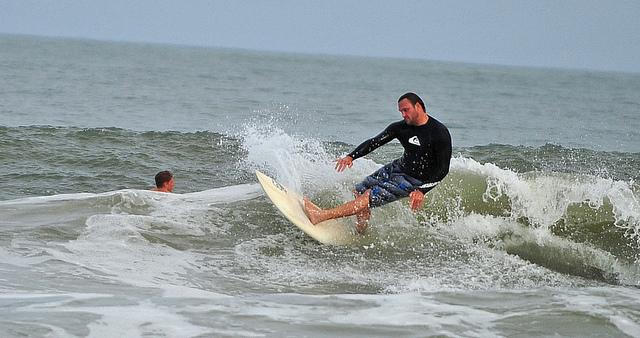Is the man getting wet?
Short answer required. Yes. How many people are near this wave?
Quick response, please. 2. Can you tell if the day is sunny?
Short answer required. Yes. 